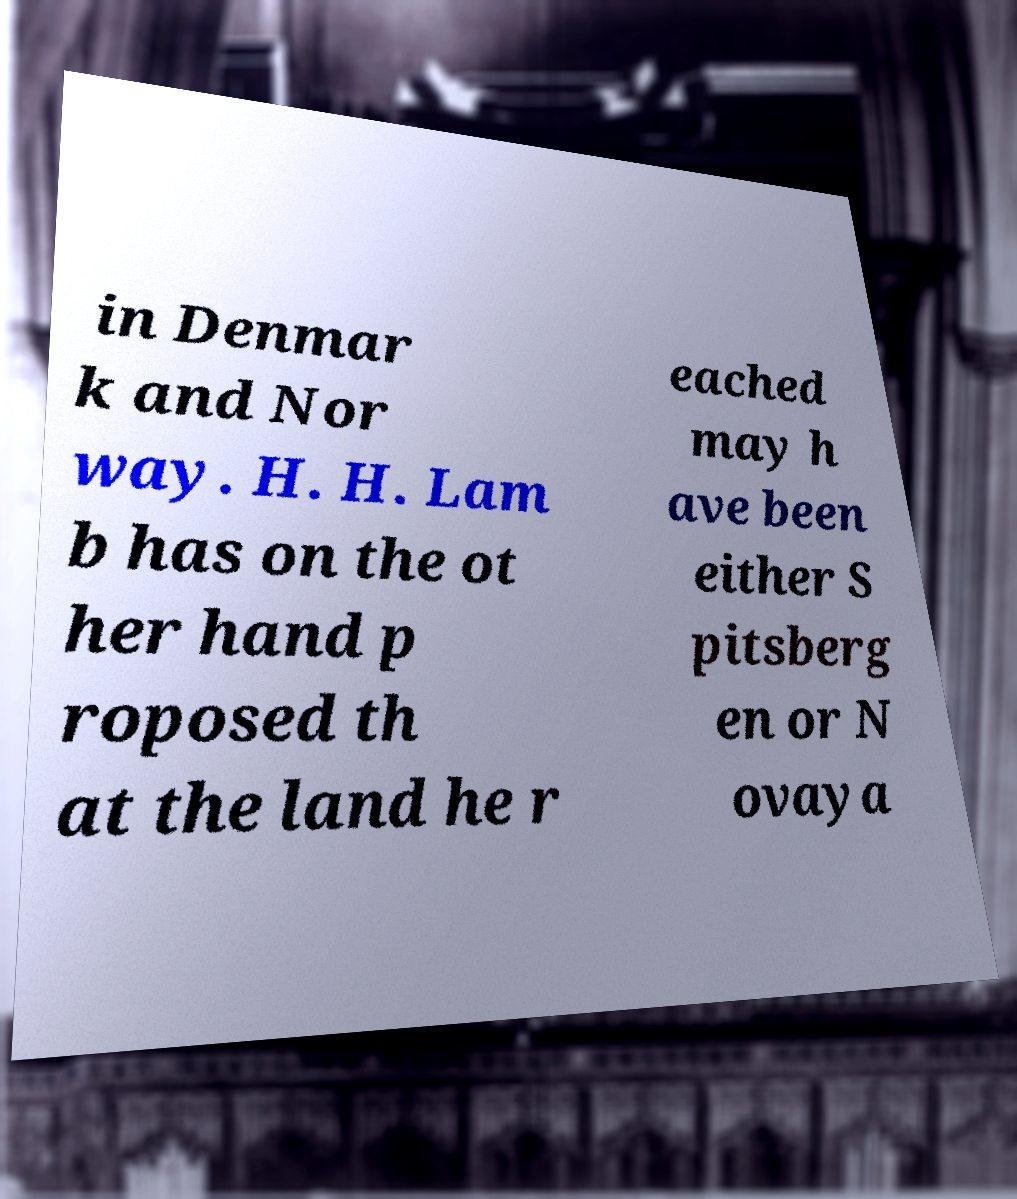Can you accurately transcribe the text from the provided image for me? in Denmar k and Nor way. H. H. Lam b has on the ot her hand p roposed th at the land he r eached may h ave been either S pitsberg en or N ovaya 